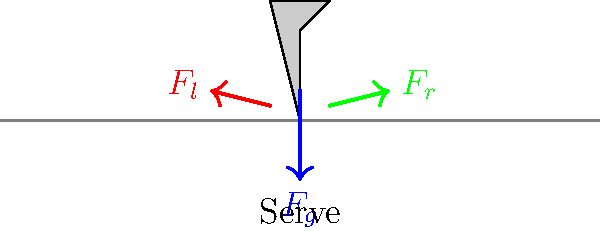During a tennis serve, which force distribution on a player's legs is most crucial for generating maximum power, and how does this differ from a groundstroke? To understand the force distribution during a tennis serve compared to a groundstroke, let's break it down step-by-step:

1. Tennis Serve:
   a) The serve begins with the player's weight distributed equally on both feet.
   b) As the player tosses the ball and begins the serving motion, weight shifts to the back foot (usually the right foot for right-handed players).
   c) During the upward motion and contact point, the player pushes off the back foot, transferring weight to the front foot.
   d) This weight transfer creates a kinetic chain, generating maximum power.

2. Groundstroke:
   a) The player starts in a ready position with weight evenly distributed.
   b) As the ball approaches, the player takes a step and shifts weight to the back foot.
   c) During the forward swing, weight transfers from the back foot to the front foot.
   d) The weight transfer is more lateral compared to the serve's vertical component.

3. Key differences:
   a) Serve: Emphasizes vertical force generation for upward reach.
   b) Groundstroke: Focuses on lateral force transfer for forward momentum.

4. Force distribution:
   a) Serve: $F_g$ (gravity) is counteracted by $F_l$ (left leg) and $F_r$ (right leg).
   b) Initially, $F_l \approx F_r$, then $F_r > F_l$ during the backswing, and finally $F_l > F_r$ at contact.
   c) Groundstroke: The force distribution shifts from back to front foot more gradually.

5. Power generation:
   a) Serve: Maximum power comes from the explosive upward push of the back leg.
   b) Groundstroke: Power is generated through a more balanced transfer from back to front.

In conclusion, the serve relies more on the explosive force from the back leg to front leg transfer, while the groundstroke uses a more balanced lateral weight shift.
Answer: Back-to-front explosive force transfer in serve; balanced lateral shift in groundstroke. 